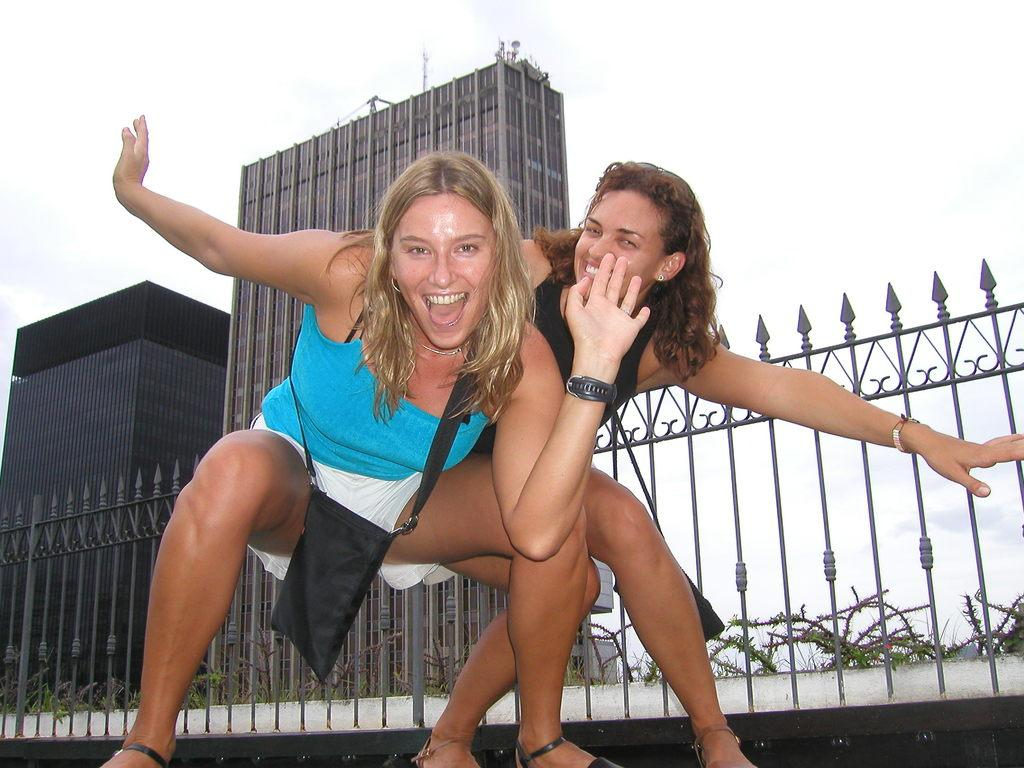How many women are in the image? There are two women in the image. What are the women doing in the image? The women are smiling in the image. Can you describe the woman on the right side of the image? The woman on the right side of the image is carrying a bag. What can be seen in the background of the image? There are buildings, a fence, plants, and the sky visible in the background of the image. What type of flowers can be seen growing on the swing in the image? There is no swing or flowers present in the image. 